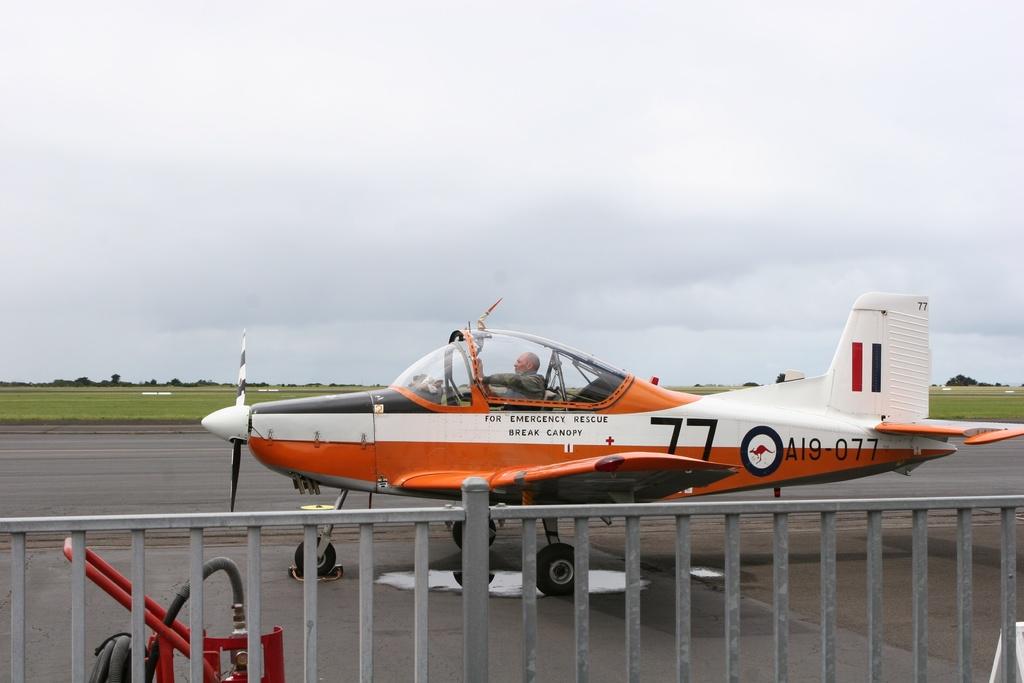What is the plan number?
Your response must be concise. 77. 